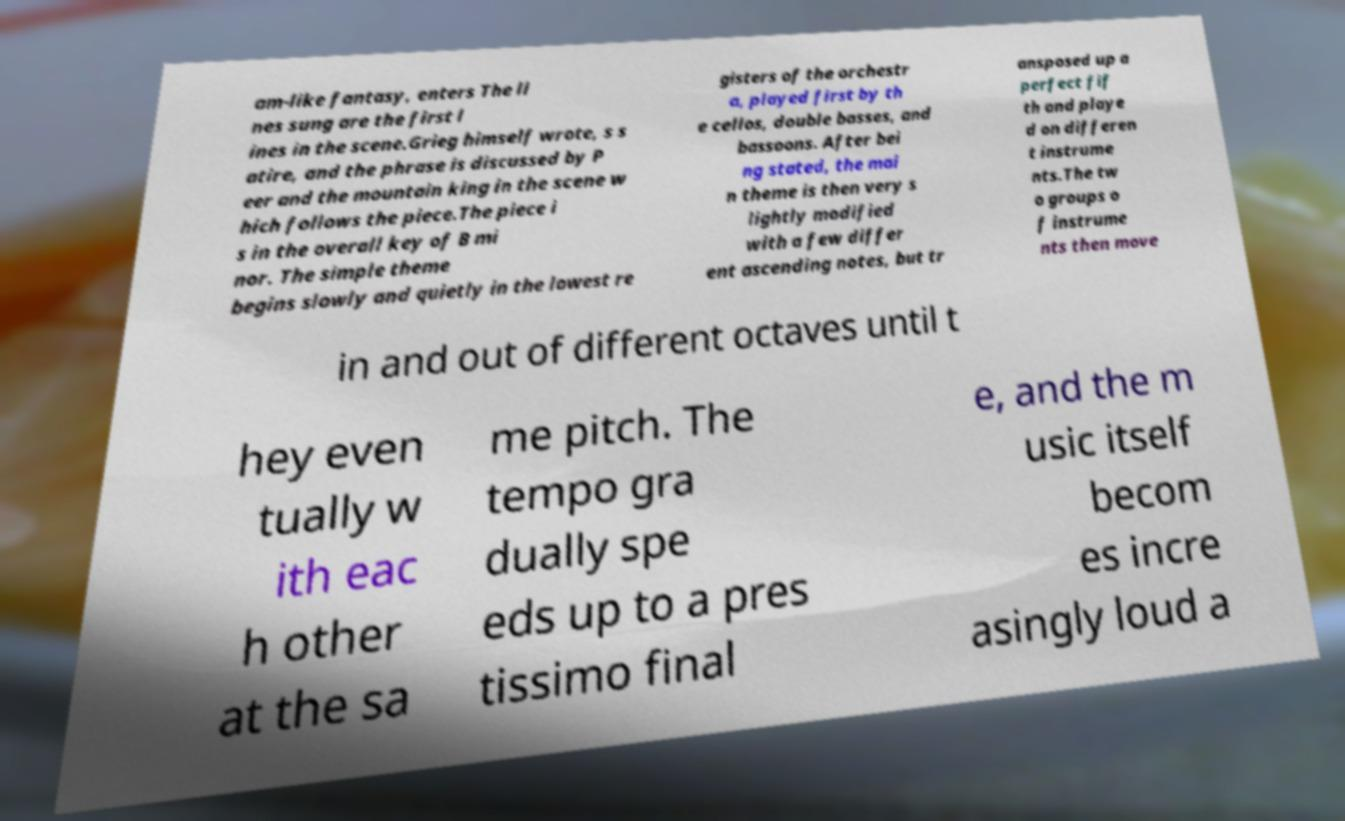For documentation purposes, I need the text within this image transcribed. Could you provide that? am-like fantasy, enters The li nes sung are the first l ines in the scene.Grieg himself wrote, s s atire, and the phrase is discussed by P eer and the mountain king in the scene w hich follows the piece.The piece i s in the overall key of B mi nor. The simple theme begins slowly and quietly in the lowest re gisters of the orchestr a, played first by th e cellos, double basses, and bassoons. After bei ng stated, the mai n theme is then very s lightly modified with a few differ ent ascending notes, but tr ansposed up a perfect fif th and playe d on differen t instrume nts.The tw o groups o f instrume nts then move in and out of different octaves until t hey even tually w ith eac h other at the sa me pitch. The tempo gra dually spe eds up to a pres tissimo final e, and the m usic itself becom es incre asingly loud a 